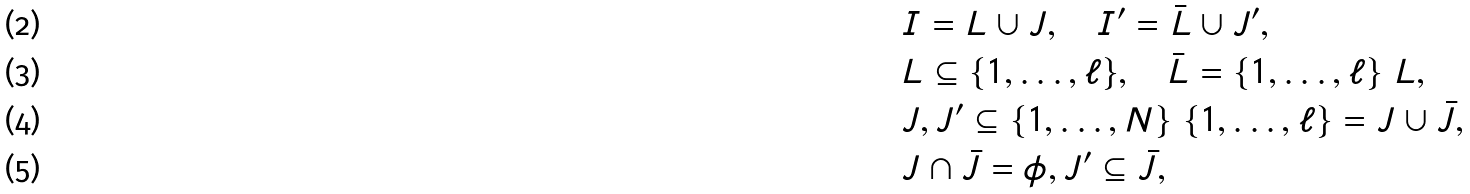<formula> <loc_0><loc_0><loc_500><loc_500>& I = L \cup J , \quad I ^ { \prime } = \bar { L } \cup J ^ { \prime } , \\ & L \subseteq \{ 1 , \dots , \ell \} , \quad \bar { L } = \{ 1 , \dots , \ell \} \ L , \\ & J , J ^ { \prime } \subseteq \{ 1 , \dots , N \} \ \{ 1 , \dots , \ell \} = J \cup \bar { J } , \\ & J \cap \bar { J } = \phi , J ^ { \prime } \subseteq \bar { J } ,</formula> 